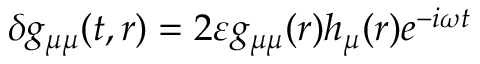<formula> <loc_0><loc_0><loc_500><loc_500>\delta g _ { \mu \mu } ( t , r ) = 2 \varepsilon g _ { \mu \mu } ( r ) h _ { \mu } ( r ) e ^ { - i \omega t }</formula> 